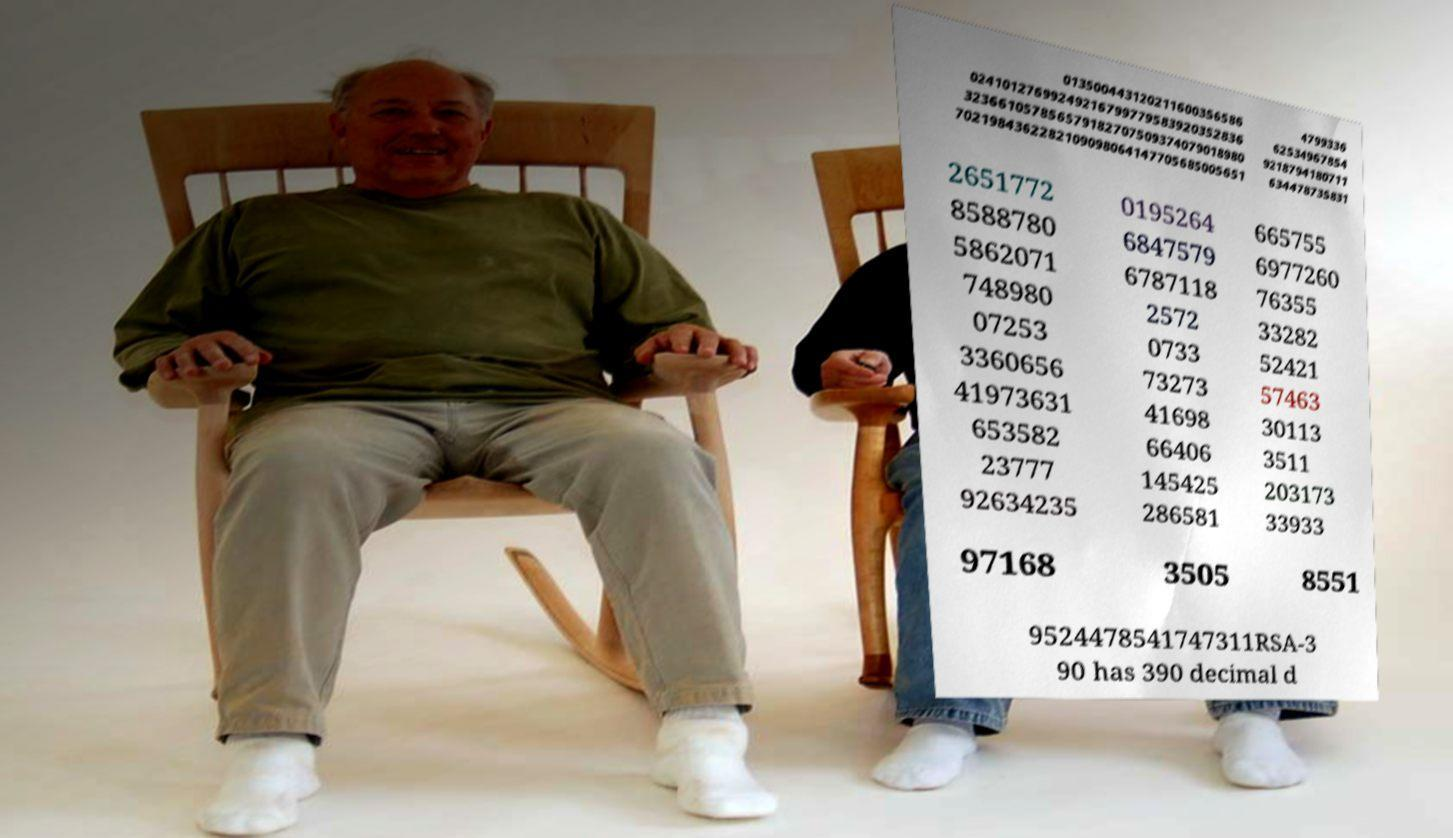Please identify and transcribe the text found in this image. 013500443120211600356586 02410127699249216799779583920352836 323661057856579182707509374079018980 7021984362282109098064147705685005651 4799336 62534967854 9218794180711 634478735831 2651772 8588780 5862071 748980 07253 3360656 41973631 653582 23777 92634235 0195264 6847579 6787118 2572 0733 73273 41698 66406 145425 286581 665755 6977260 76355 33282 52421 57463 30113 3511 203173 33933 97168 3505 8551 9524478541747311RSA-3 90 has 390 decimal d 